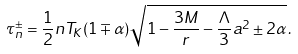Convert formula to latex. <formula><loc_0><loc_0><loc_500><loc_500>\tau ^ { \pm } _ { n } = \frac { 1 } { 2 } n T _ { K } ( 1 \mp \alpha ) \sqrt { 1 - \frac { 3 M } { r } - \frac { \Lambda } { 3 } a ^ { 2 } \pm 2 \alpha } \, .</formula> 